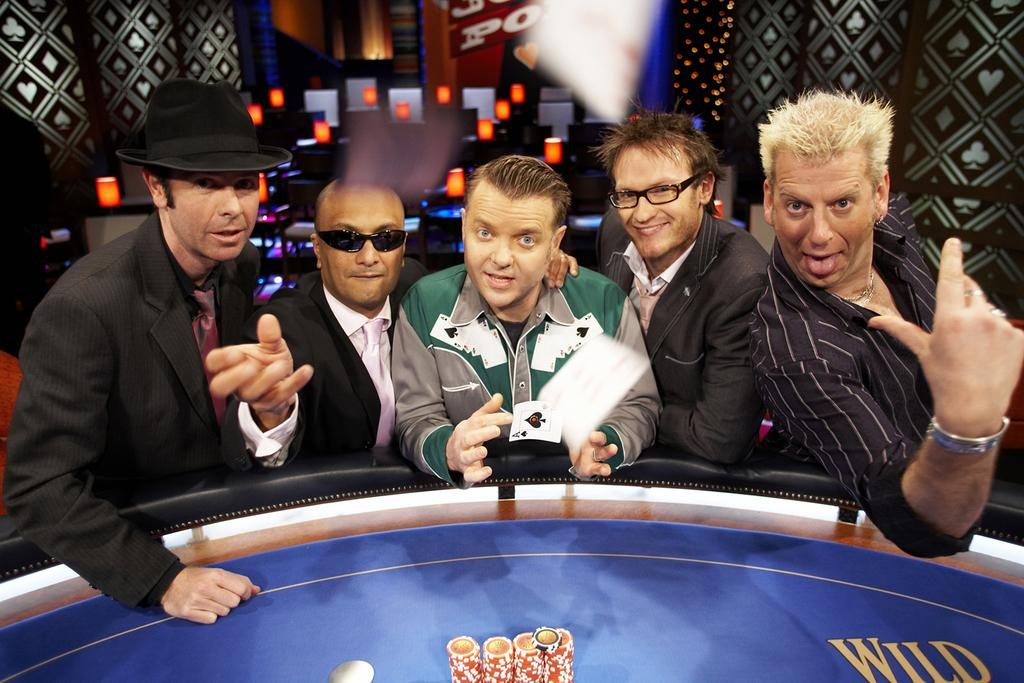What can be seen in the image? There are people standing in the image. What is the blue object in the image? There is a blue color board in the image. What is on the blue color board? There is something on the blue color board. How would you describe the background of the image? The background of the image is colorful. Can you identify any objects in the image? Yes, there are objects visible in the image. What type of sound can be heard coming from the notebook in the image? There is no notebook present in the image, and therefore no sound can be heard from it. 